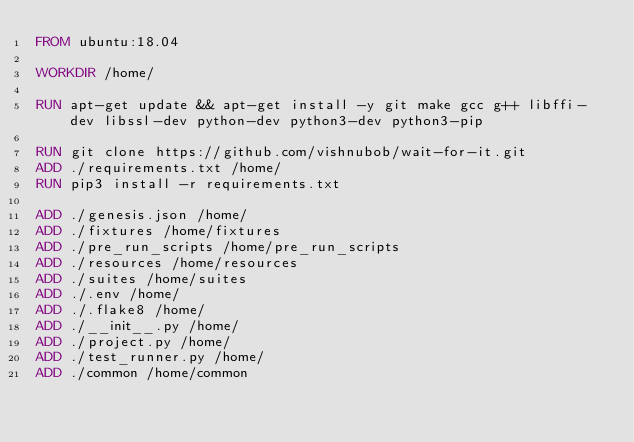<code> <loc_0><loc_0><loc_500><loc_500><_Dockerfile_>FROM ubuntu:18.04

WORKDIR /home/

RUN apt-get update && apt-get install -y git make gcc g++ libffi-dev libssl-dev python-dev python3-dev python3-pip

RUN git clone https://github.com/vishnubob/wait-for-it.git
ADD ./requirements.txt /home/
RUN pip3 install -r requirements.txt

ADD ./genesis.json /home/
ADD ./fixtures /home/fixtures
ADD ./pre_run_scripts /home/pre_run_scripts
ADD ./resources /home/resources
ADD ./suites /home/suites
ADD ./.env /home/
ADD ./.flake8 /home/
ADD ./__init__.py /home/
ADD ./project.py /home/
ADD ./test_runner.py /home/
ADD ./common /home/common
</code> 